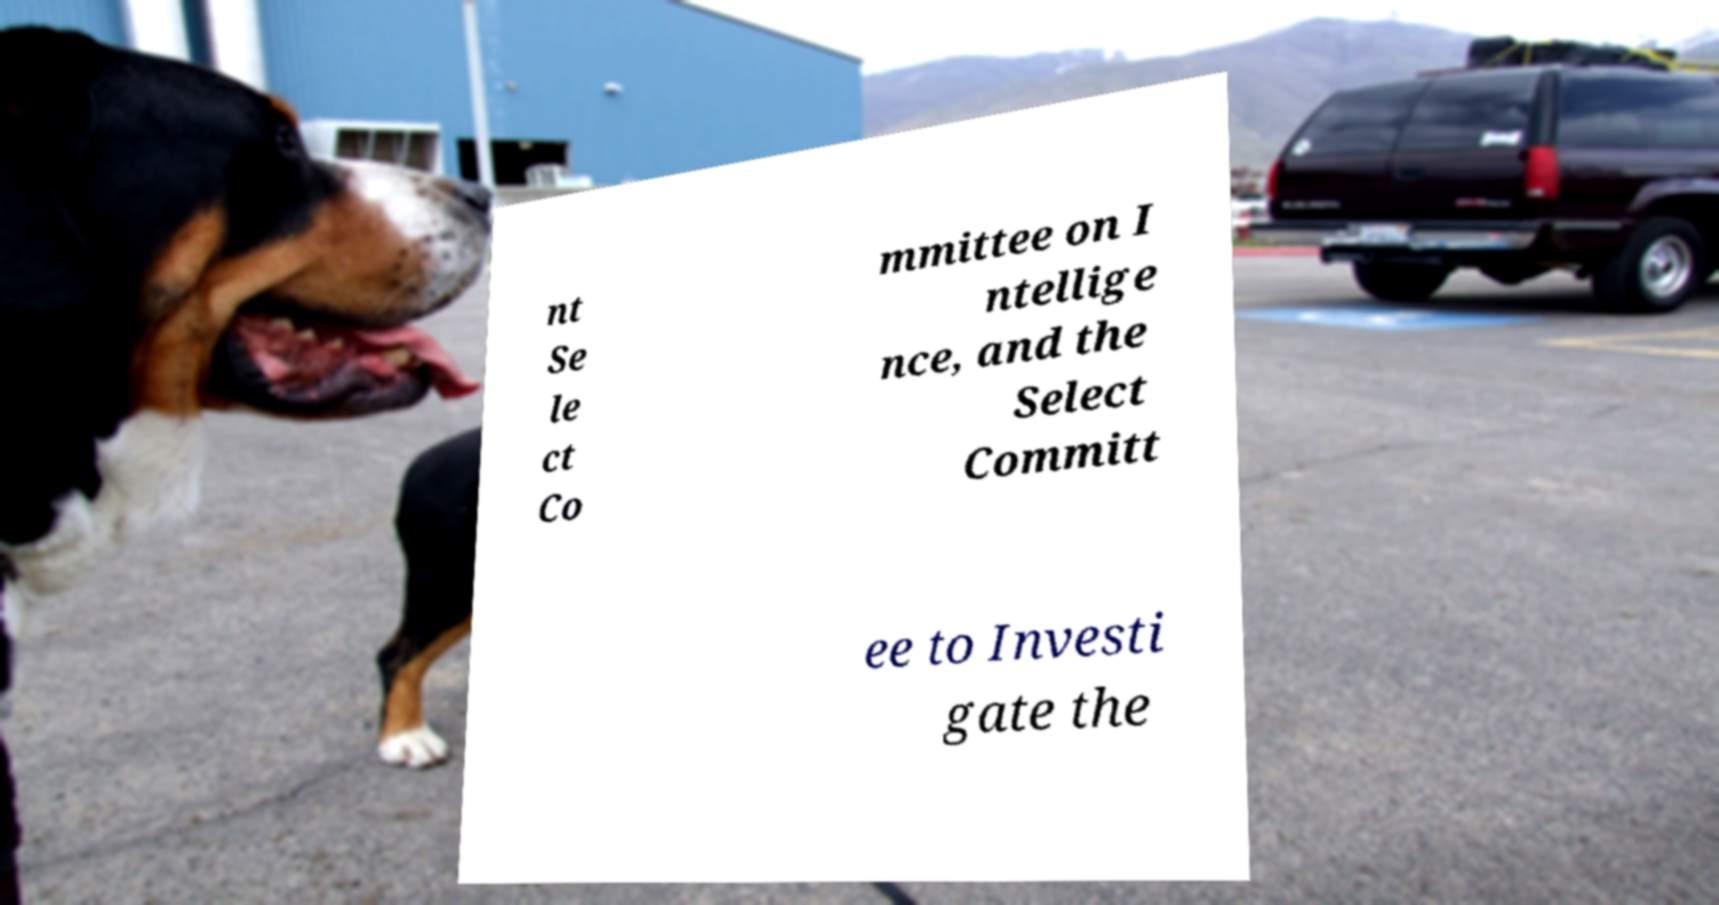For documentation purposes, I need the text within this image transcribed. Could you provide that? nt Se le ct Co mmittee on I ntellige nce, and the Select Committ ee to Investi gate the 